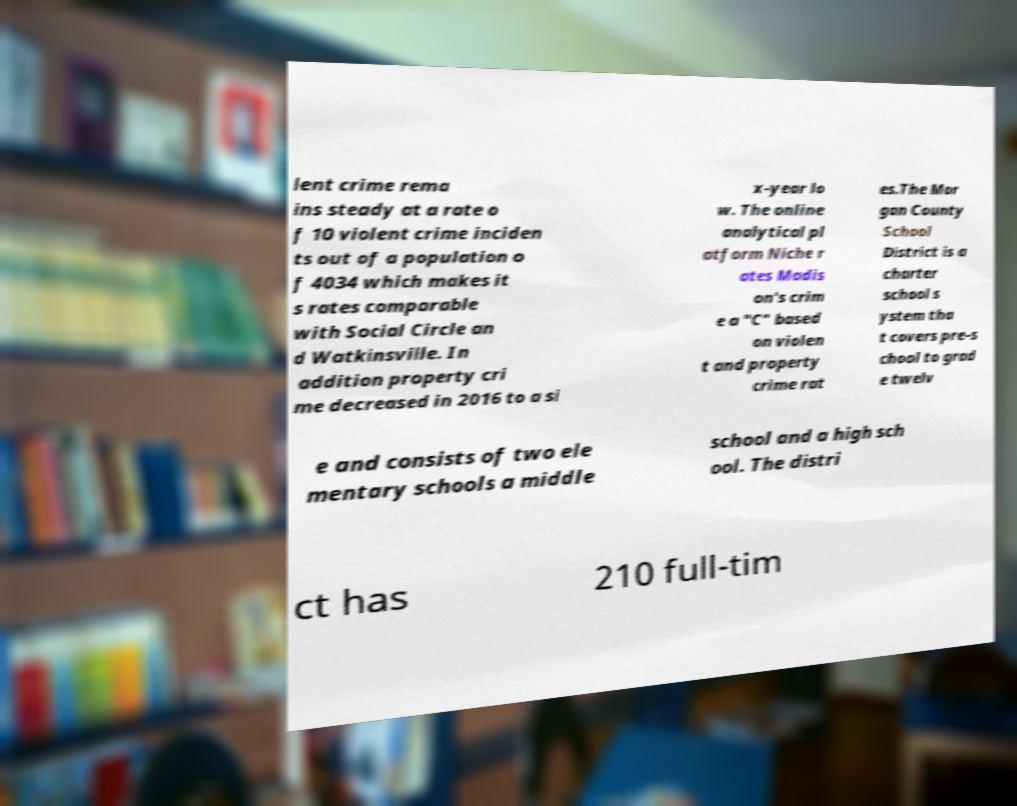Please read and relay the text visible in this image. What does it say? lent crime rema ins steady at a rate o f 10 violent crime inciden ts out of a population o f 4034 which makes it s rates comparable with Social Circle an d Watkinsville. In addition property cri me decreased in 2016 to a si x-year lo w. The online analytical pl atform Niche r ates Madis on's crim e a "C" based on violen t and property crime rat es.The Mor gan County School District is a charter school s ystem tha t covers pre-s chool to grad e twelv e and consists of two ele mentary schools a middle school and a high sch ool. The distri ct has 210 full-tim 